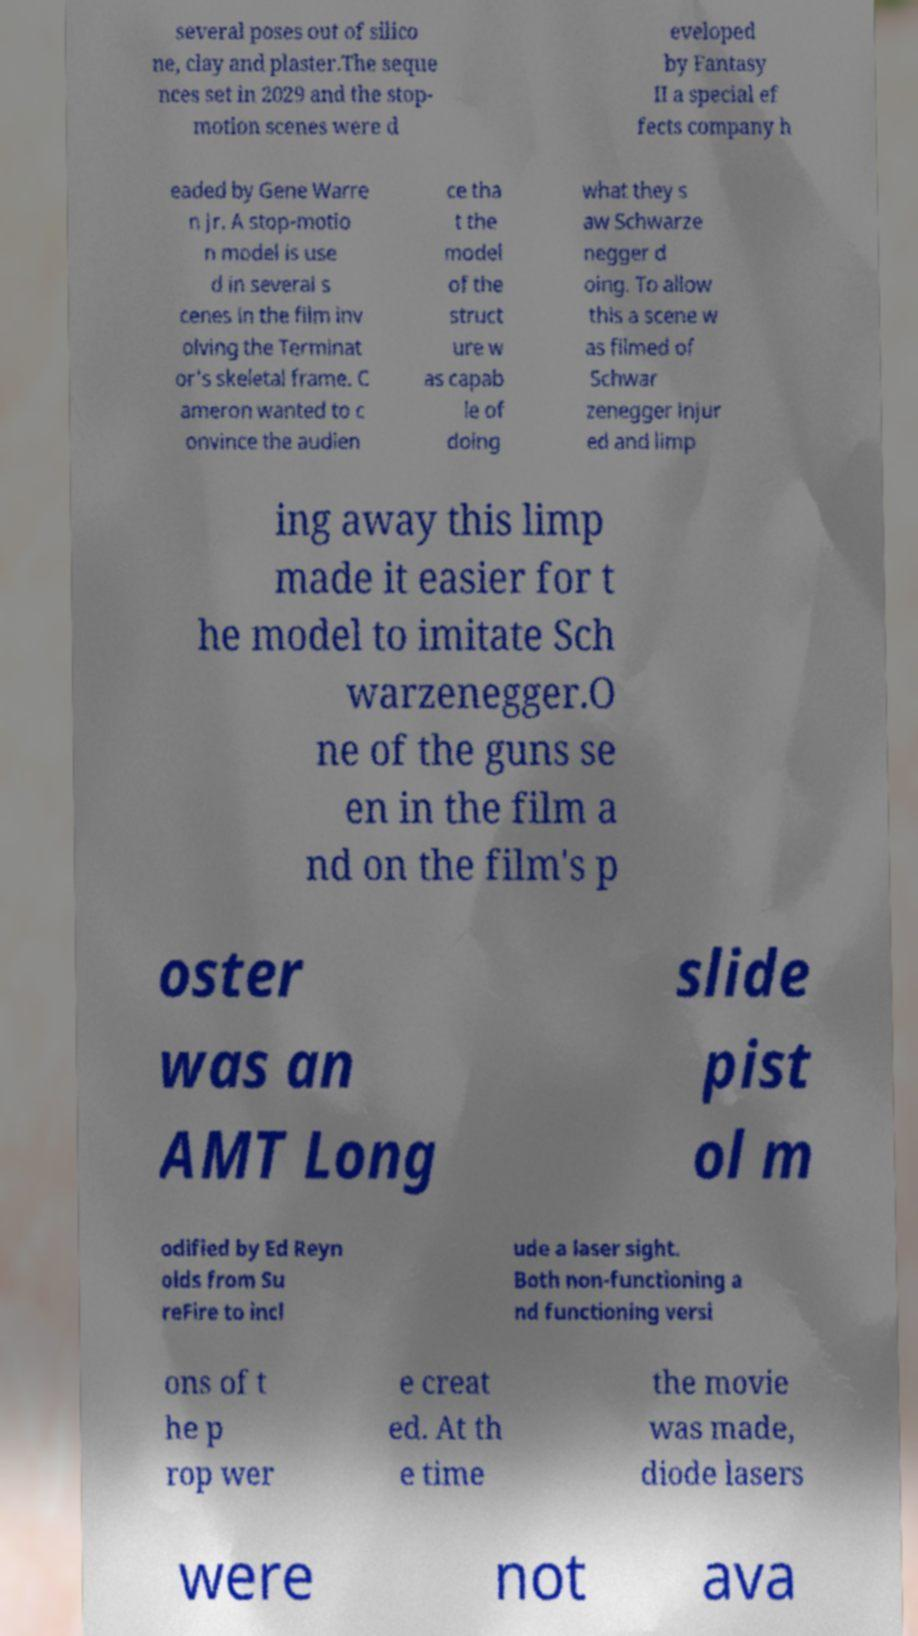For documentation purposes, I need the text within this image transcribed. Could you provide that? several poses out of silico ne, clay and plaster.The seque nces set in 2029 and the stop- motion scenes were d eveloped by Fantasy II a special ef fects company h eaded by Gene Warre n Jr. A stop-motio n model is use d in several s cenes in the film inv olving the Terminat or's skeletal frame. C ameron wanted to c onvince the audien ce tha t the model of the struct ure w as capab le of doing what they s aw Schwarze negger d oing. To allow this a scene w as filmed of Schwar zenegger injur ed and limp ing away this limp made it easier for t he model to imitate Sch warzenegger.O ne of the guns se en in the film a nd on the film's p oster was an AMT Long slide pist ol m odified by Ed Reyn olds from Su reFire to incl ude a laser sight. Both non-functioning a nd functioning versi ons of t he p rop wer e creat ed. At th e time the movie was made, diode lasers were not ava 